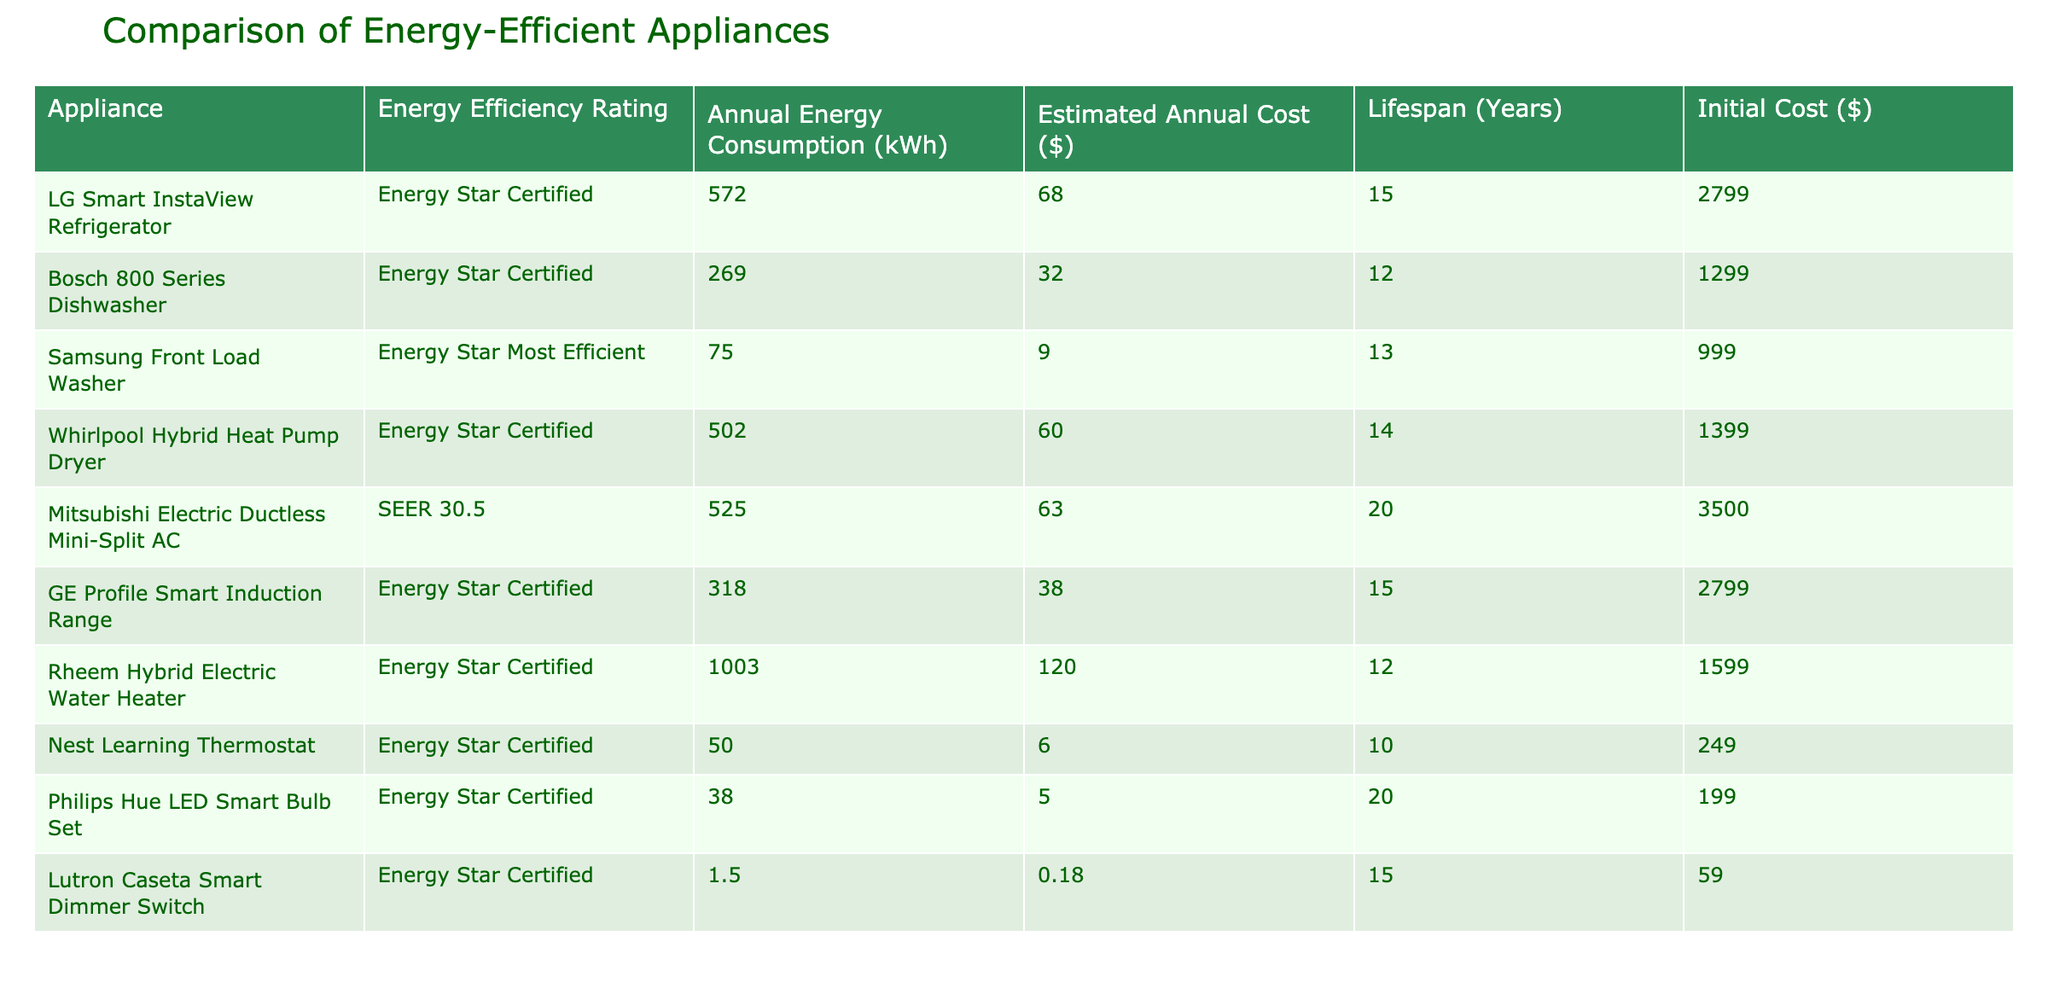What is the energy efficiency rating of Samsung Front Load Washer? The table lists the energy efficiency rating for each appliance, and for the Samsung Front Load Washer, it is "Energy Star Most Efficient."
Answer: Energy Star Most Efficient Which appliance has the highest annual energy consumption? By looking at the "Annual Energy Consumption (kWh)" column, the Rheem Hybrid Electric Water Heater has the highest value, which is 1003 kWh.
Answer: 1003 kWh What is the total estimated annual cost for all appliances combined? To calculate the total estimated annual cost, we sum the estimated annual costs: 68 + 32 + 9 + 60 + 63 + 38 + 120 + 6 + 5 + 0.18 = 401.18.
Answer: 401.18 Is the lifespan of the LG Smart InstaView Refrigerator greater than 15 years? According to the table, the lifespan of the LG Smart InstaView Refrigerator is noted as 15 years, confirming that it is not greater.
Answer: No Which appliance has the lowest initial cost, and what is that cost? Examining the "Initial Cost ($)" column reveals that the Lutron Caseta Smart Dimmer Switch has the lowest initial cost at $59.
Answer: $59 If calculating the average annual energy consumption of all appliances, what would it be? To find the average, first sum all annual energy consumption values: 572 + 269 + 75 + 502 + 525 + 318 + 1003 + 50 + 38 + 1.5 = 3354.5, then divide by the number of appliances (10), which gives 335.45 kWh.
Answer: 335.45 kWh Is the estimated annual cost of the Mitsubishi Electric Ductless Mini-Split AC less than the average estimated annual cost? The estimated annual costs from the table are 68, 32, 9, 60, 63, 38, 120, 6, 5, 0.18. The average is calculated as follows: (68 + 32 + 9 + 60 + 63 + 38 + 120 + 6 + 5 + 0.18)/10 = 40.08. Since Mitsubishi's cost is 63, it is greater.
Answer: No What is the difference in lifespan between the Bosch 800 Series Dishwasher and the Rheem Hybrid Electric Water Heater? The table shows that the Bosch 800 Series Dishwasher has a lifespan of 12 years, while the Rheem Hybrid Electric Water Heater has a lifespan of 12 years. Therefore, the difference is 12 - 12 = 0 years.
Answer: 0 years 